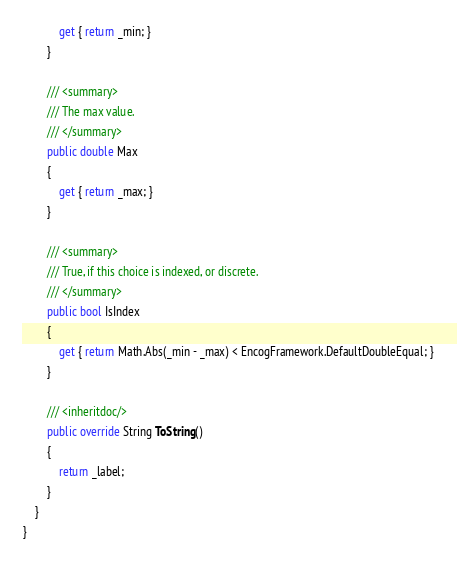<code> <loc_0><loc_0><loc_500><loc_500><_C#_>            get { return _min; }
        }

        /// <summary>
        /// The max value.
        /// </summary>
        public double Max
        {
            get { return _max; }
        }

        /// <summary>
        /// True, if this choice is indexed, or discrete.
        /// </summary>
        public bool IsIndex
        {
            get { return Math.Abs(_min - _max) < EncogFramework.DefaultDoubleEqual; }
        }

        /// <inheritdoc/>
        public override String ToString()
        {
            return _label;
        }
    }
}
</code> 